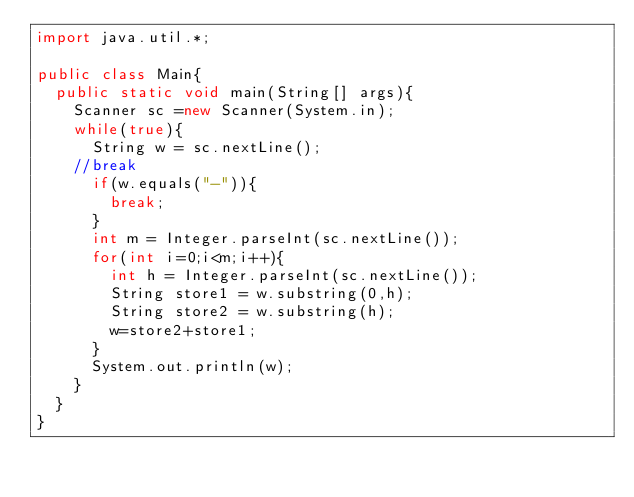Convert code to text. <code><loc_0><loc_0><loc_500><loc_500><_Java_>import java.util.*;

public class Main{
	public static void main(String[] args){
		Scanner sc =new Scanner(System.in);
		while(true){
			String w = sc.nextLine();
		//break	
			if(w.equals("-")){
				break;
			}
			int m = Integer.parseInt(sc.nextLine());
			for(int i=0;i<m;i++){
				int h = Integer.parseInt(sc.nextLine());
				String store1 = w.substring(0,h);
				String store2 = w.substring(h);
				w=store2+store1;
			}
			System.out.println(w);
		}
	}
}</code> 